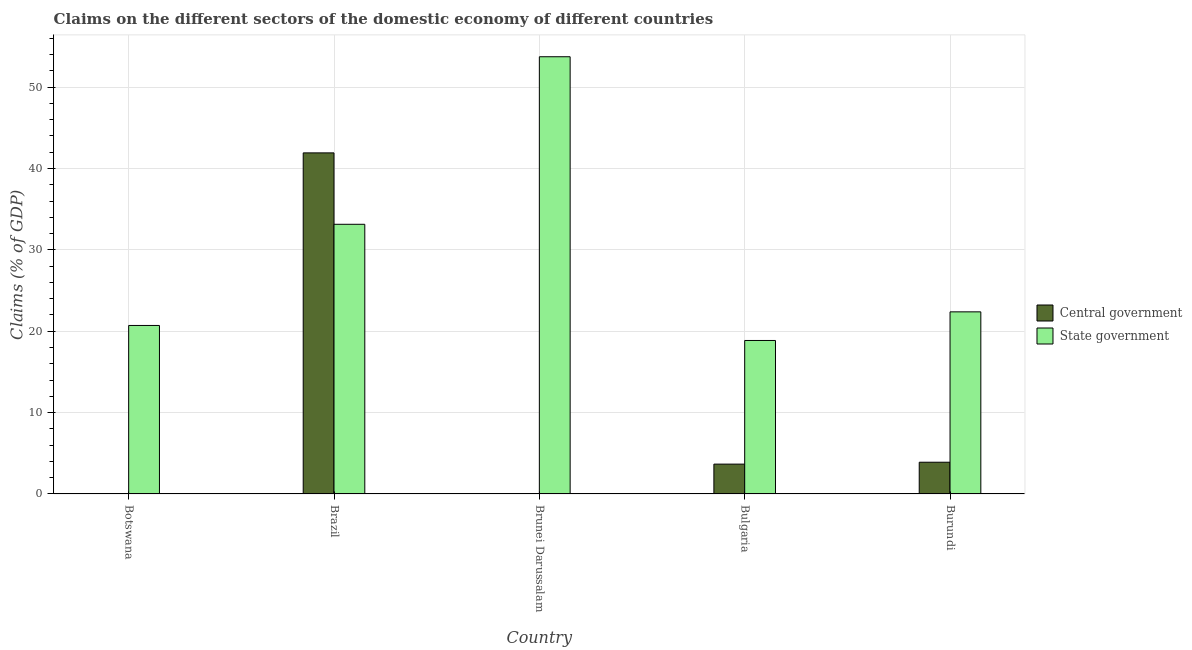Are the number of bars per tick equal to the number of legend labels?
Ensure brevity in your answer.  No. How many bars are there on the 1st tick from the left?
Your response must be concise. 1. How many bars are there on the 1st tick from the right?
Provide a short and direct response. 2. In how many cases, is the number of bars for a given country not equal to the number of legend labels?
Ensure brevity in your answer.  2. What is the claims on state government in Brazil?
Your answer should be compact. 33.14. Across all countries, what is the maximum claims on central government?
Your answer should be compact. 41.92. Across all countries, what is the minimum claims on state government?
Provide a short and direct response. 18.86. In which country was the claims on state government maximum?
Your answer should be very brief. Brunei Darussalam. What is the total claims on central government in the graph?
Offer a terse response. 49.49. What is the difference between the claims on state government in Brunei Darussalam and that in Bulgaria?
Offer a terse response. 34.87. What is the difference between the claims on central government in Brazil and the claims on state government in Botswana?
Provide a succinct answer. 21.21. What is the average claims on state government per country?
Ensure brevity in your answer.  29.77. What is the difference between the claims on central government and claims on state government in Burundi?
Keep it short and to the point. -18.48. In how many countries, is the claims on state government greater than 40 %?
Ensure brevity in your answer.  1. What is the ratio of the claims on central government in Bulgaria to that in Burundi?
Your answer should be compact. 0.94. Is the claims on state government in Botswana less than that in Burundi?
Your answer should be very brief. Yes. What is the difference between the highest and the second highest claims on state government?
Offer a terse response. 20.59. What is the difference between the highest and the lowest claims on central government?
Your answer should be very brief. 41.92. In how many countries, is the claims on central government greater than the average claims on central government taken over all countries?
Your answer should be compact. 1. Is the sum of the claims on state government in Brunei Darussalam and Burundi greater than the maximum claims on central government across all countries?
Give a very brief answer. Yes. How many bars are there?
Offer a very short reply. 8. How many countries are there in the graph?
Provide a succinct answer. 5. What is the difference between two consecutive major ticks on the Y-axis?
Keep it short and to the point. 10. Does the graph contain grids?
Provide a succinct answer. Yes. Where does the legend appear in the graph?
Your answer should be compact. Center right. How are the legend labels stacked?
Give a very brief answer. Vertical. What is the title of the graph?
Give a very brief answer. Claims on the different sectors of the domestic economy of different countries. What is the label or title of the Y-axis?
Ensure brevity in your answer.  Claims (% of GDP). What is the Claims (% of GDP) in State government in Botswana?
Your response must be concise. 20.71. What is the Claims (% of GDP) of Central government in Brazil?
Your answer should be compact. 41.92. What is the Claims (% of GDP) of State government in Brazil?
Give a very brief answer. 33.14. What is the Claims (% of GDP) of Central government in Brunei Darussalam?
Provide a short and direct response. 0. What is the Claims (% of GDP) of State government in Brunei Darussalam?
Ensure brevity in your answer.  53.73. What is the Claims (% of GDP) in Central government in Bulgaria?
Offer a terse response. 3.67. What is the Claims (% of GDP) of State government in Bulgaria?
Offer a terse response. 18.86. What is the Claims (% of GDP) of Central government in Burundi?
Give a very brief answer. 3.9. What is the Claims (% of GDP) in State government in Burundi?
Provide a succinct answer. 22.38. Across all countries, what is the maximum Claims (% of GDP) in Central government?
Give a very brief answer. 41.92. Across all countries, what is the maximum Claims (% of GDP) in State government?
Give a very brief answer. 53.73. Across all countries, what is the minimum Claims (% of GDP) of State government?
Ensure brevity in your answer.  18.86. What is the total Claims (% of GDP) of Central government in the graph?
Provide a short and direct response. 49.49. What is the total Claims (% of GDP) in State government in the graph?
Ensure brevity in your answer.  148.83. What is the difference between the Claims (% of GDP) in State government in Botswana and that in Brazil?
Make the answer very short. -12.43. What is the difference between the Claims (% of GDP) of State government in Botswana and that in Brunei Darussalam?
Make the answer very short. -33.02. What is the difference between the Claims (% of GDP) of State government in Botswana and that in Bulgaria?
Make the answer very short. 1.85. What is the difference between the Claims (% of GDP) of State government in Botswana and that in Burundi?
Give a very brief answer. -1.67. What is the difference between the Claims (% of GDP) of State government in Brazil and that in Brunei Darussalam?
Give a very brief answer. -20.59. What is the difference between the Claims (% of GDP) of Central government in Brazil and that in Bulgaria?
Provide a succinct answer. 38.25. What is the difference between the Claims (% of GDP) in State government in Brazil and that in Bulgaria?
Provide a short and direct response. 14.28. What is the difference between the Claims (% of GDP) of Central government in Brazil and that in Burundi?
Make the answer very short. 38.02. What is the difference between the Claims (% of GDP) in State government in Brazil and that in Burundi?
Offer a very short reply. 10.76. What is the difference between the Claims (% of GDP) in State government in Brunei Darussalam and that in Bulgaria?
Keep it short and to the point. 34.87. What is the difference between the Claims (% of GDP) in State government in Brunei Darussalam and that in Burundi?
Offer a terse response. 31.35. What is the difference between the Claims (% of GDP) in Central government in Bulgaria and that in Burundi?
Provide a short and direct response. -0.23. What is the difference between the Claims (% of GDP) in State government in Bulgaria and that in Burundi?
Your answer should be compact. -3.52. What is the difference between the Claims (% of GDP) in Central government in Brazil and the Claims (% of GDP) in State government in Brunei Darussalam?
Make the answer very short. -11.81. What is the difference between the Claims (% of GDP) in Central government in Brazil and the Claims (% of GDP) in State government in Bulgaria?
Your response must be concise. 23.06. What is the difference between the Claims (% of GDP) in Central government in Brazil and the Claims (% of GDP) in State government in Burundi?
Make the answer very short. 19.54. What is the difference between the Claims (% of GDP) in Central government in Bulgaria and the Claims (% of GDP) in State government in Burundi?
Offer a terse response. -18.71. What is the average Claims (% of GDP) in Central government per country?
Provide a succinct answer. 9.9. What is the average Claims (% of GDP) of State government per country?
Your answer should be very brief. 29.77. What is the difference between the Claims (% of GDP) in Central government and Claims (% of GDP) in State government in Brazil?
Offer a terse response. 8.78. What is the difference between the Claims (% of GDP) of Central government and Claims (% of GDP) of State government in Bulgaria?
Provide a succinct answer. -15.19. What is the difference between the Claims (% of GDP) of Central government and Claims (% of GDP) of State government in Burundi?
Your answer should be compact. -18.48. What is the ratio of the Claims (% of GDP) in State government in Botswana to that in Brazil?
Provide a short and direct response. 0.62. What is the ratio of the Claims (% of GDP) in State government in Botswana to that in Brunei Darussalam?
Offer a terse response. 0.39. What is the ratio of the Claims (% of GDP) in State government in Botswana to that in Bulgaria?
Provide a succinct answer. 1.1. What is the ratio of the Claims (% of GDP) of State government in Botswana to that in Burundi?
Make the answer very short. 0.93. What is the ratio of the Claims (% of GDP) of State government in Brazil to that in Brunei Darussalam?
Your answer should be compact. 0.62. What is the ratio of the Claims (% of GDP) in Central government in Brazil to that in Bulgaria?
Give a very brief answer. 11.43. What is the ratio of the Claims (% of GDP) of State government in Brazil to that in Bulgaria?
Your answer should be very brief. 1.76. What is the ratio of the Claims (% of GDP) in Central government in Brazil to that in Burundi?
Provide a succinct answer. 10.74. What is the ratio of the Claims (% of GDP) in State government in Brazil to that in Burundi?
Offer a terse response. 1.48. What is the ratio of the Claims (% of GDP) of State government in Brunei Darussalam to that in Bulgaria?
Your response must be concise. 2.85. What is the ratio of the Claims (% of GDP) of State government in Brunei Darussalam to that in Burundi?
Ensure brevity in your answer.  2.4. What is the ratio of the Claims (% of GDP) of Central government in Bulgaria to that in Burundi?
Make the answer very short. 0.94. What is the ratio of the Claims (% of GDP) of State government in Bulgaria to that in Burundi?
Provide a short and direct response. 0.84. What is the difference between the highest and the second highest Claims (% of GDP) of Central government?
Keep it short and to the point. 38.02. What is the difference between the highest and the second highest Claims (% of GDP) of State government?
Your answer should be compact. 20.59. What is the difference between the highest and the lowest Claims (% of GDP) in Central government?
Make the answer very short. 41.92. What is the difference between the highest and the lowest Claims (% of GDP) of State government?
Your response must be concise. 34.87. 